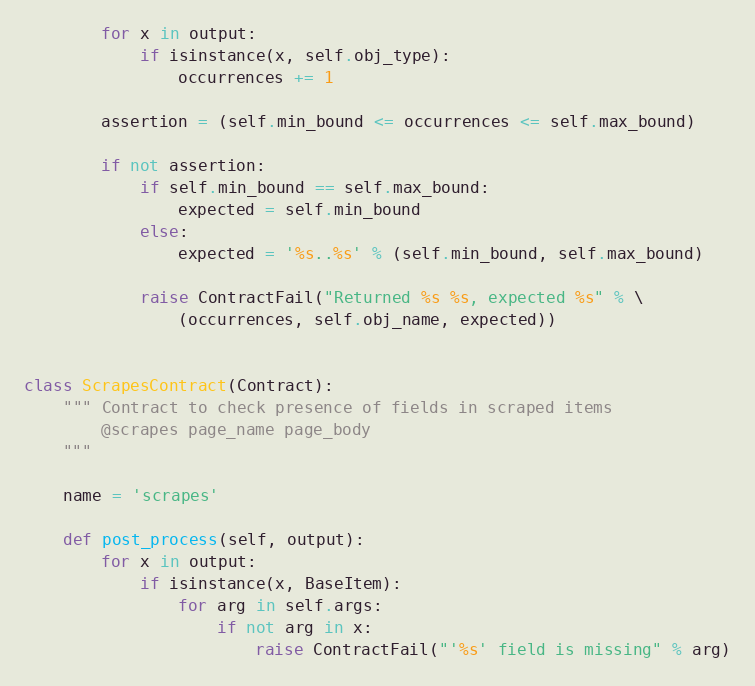<code> <loc_0><loc_0><loc_500><loc_500><_Python_>        for x in output:
            if isinstance(x, self.obj_type):
                occurrences += 1

        assertion = (self.min_bound <= occurrences <= self.max_bound)

        if not assertion:
            if self.min_bound == self.max_bound:
                expected = self.min_bound
            else:
                expected = '%s..%s' % (self.min_bound, self.max_bound)

            raise ContractFail("Returned %s %s, expected %s" % \
                (occurrences, self.obj_name, expected))


class ScrapesContract(Contract):
    """ Contract to check presence of fields in scraped items
        @scrapes page_name page_body
    """

    name = 'scrapes'

    def post_process(self, output):
        for x in output:
            if isinstance(x, BaseItem):
                for arg in self.args:
                    if not arg in x:
                        raise ContractFail("'%s' field is missing" % arg)
</code> 